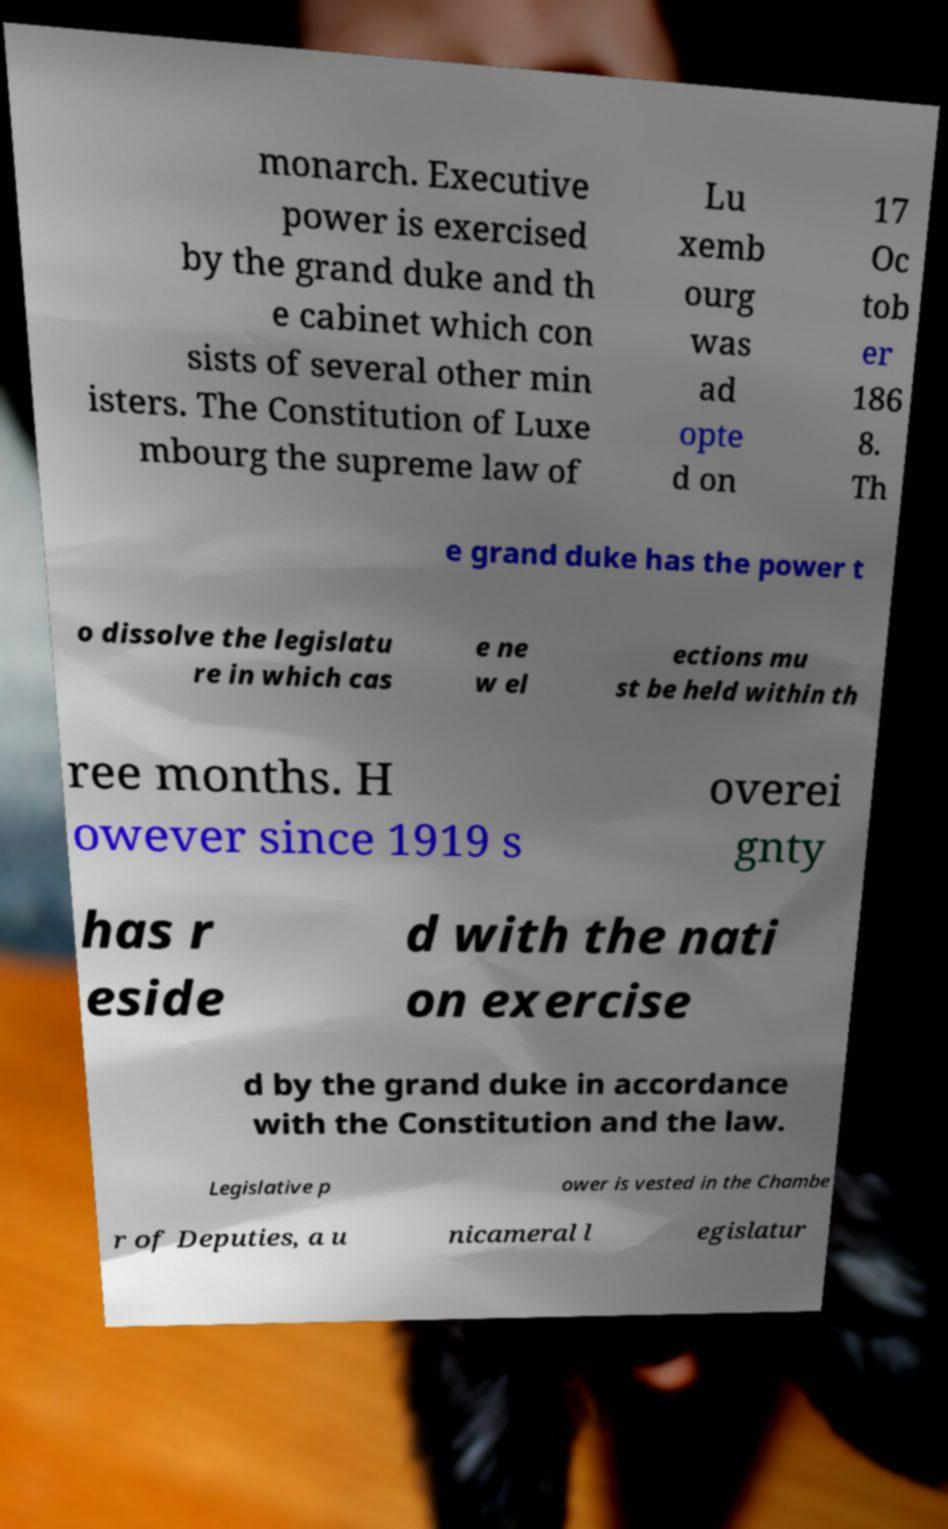Please read and relay the text visible in this image. What does it say? monarch. Executive power is exercised by the grand duke and th e cabinet which con sists of several other min isters. The Constitution of Luxe mbourg the supreme law of Lu xemb ourg was ad opte d on 17 Oc tob er 186 8. Th e grand duke has the power t o dissolve the legislatu re in which cas e ne w el ections mu st be held within th ree months. H owever since 1919 s overei gnty has r eside d with the nati on exercise d by the grand duke in accordance with the Constitution and the law. Legislative p ower is vested in the Chambe r of Deputies, a u nicameral l egislatur 